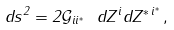Convert formula to latex. <formula><loc_0><loc_0><loc_500><loc_500>d s ^ { 2 } = 2 \mathcal { G } _ { i i ^ { * } } \ d Z ^ { i } d Z ^ { * \, i ^ { * } } \, ,</formula> 